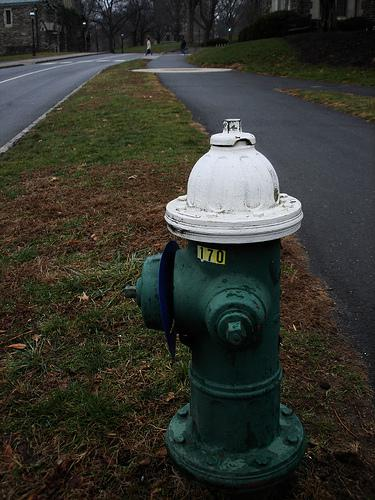Question: why is the hydrant by the sidewalk?
Choices:
A. For firefighters to use.
B. To put out fires.
C. To access water.
D. There are fire hazards in the area.
Answer with the letter. Answer: A Question: what number is on the hydrant?
Choices:
A. 5.
B. 6.
C. 3.
D. 170.
Answer with the letter. Answer: D Question: when was this taken?
Choices:
A. During the day.
B. Yesterday.
C. Noon.
D. Today.
Answer with the letter. Answer: A Question: where is the hydrant?
Choices:
A. By the tree.
B. In the dirt.
C. Next to the house.
D. In the grass.
Answer with the letter. Answer: D 